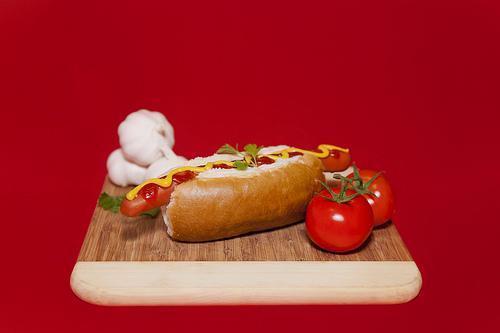How many hot dogs are there?
Give a very brief answer. 1. 